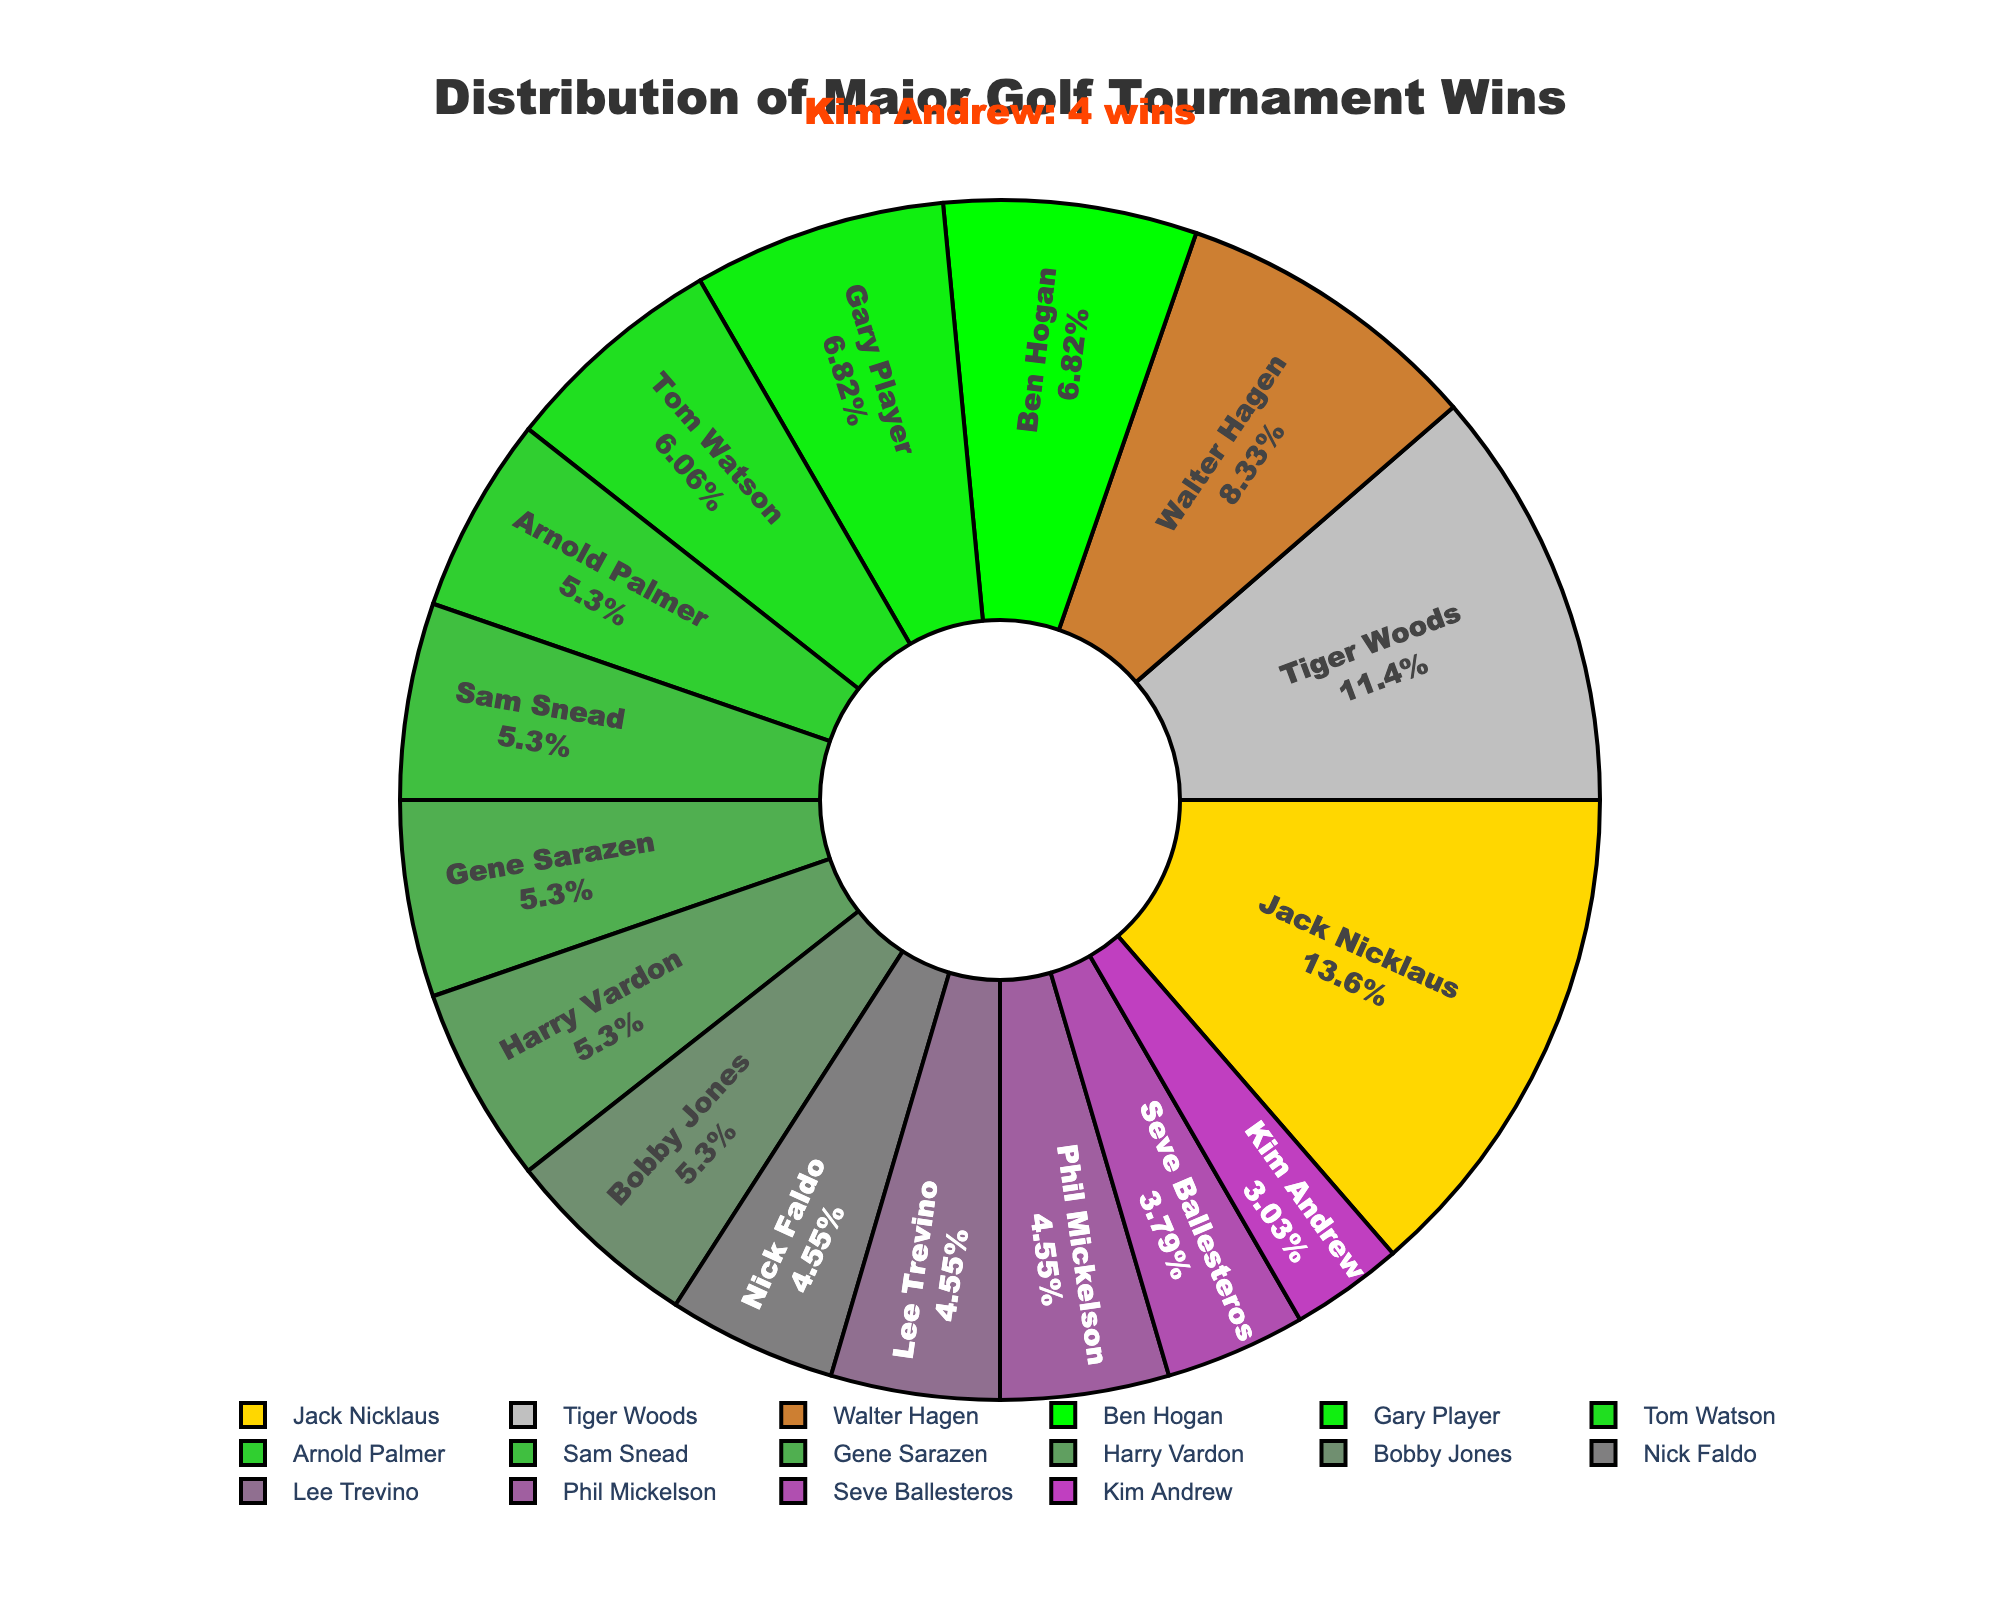What percentage of the total major wins does Kim Andrew have? First, identify Kim Andrew's segment in the pie chart which indicates 4 wins. Then sum the total number of major wins of all players. Total wins = 15 + 18 + 11 + 9 + 9 + 8 + 7 + 7 + 7 + 7 + 7 + 6 + 6 + 5 + 6 + 4 = 132. The percentage is calculated as (4 / 132) * 100 ≈ 3.03%.
Answer: 3.03% How many more major wins does Jack Nicklaus have than Kim Andrew? Locate Jack Nicklaus's segment showing 18 wins and Kim Andrew's segment showing 4 wins. Subtract the wins of Kim Andrew from those of Jack Nicklaus: 18 - 4 = 14.
Answer: 14 Who has a greater number of Major wins, Sam Snead or Kim Andrew, and by how much? Sam Snead has 7 wins, and Kim Andrew has 4 wins. Subtract Kim Andrew's wins from Sam Snead's wins: 7 - 4 = 3.
Answer: Sam Snead by 3 What is the combined total of major wins for Tiger Woods and Ben Hogan? Tiger Woods has 15 wins and Ben Hogan has 9 wins. Add their wins together: 15 + 9 = 24.
Answer: 24 Which player has the third highest number of major wins? First, list the players by their wins in descending order: Jack Nicklaus (18), Tiger Woods (15), Walter Hagen (11). Walter Hagen is third with 11 wins.
Answer: Walter Hagen How many players have won more majors than Kim Andrew? Identify the number of players with more than 4 major wins. They are: Tiger Woods, Jack Nicklaus, Walter Hagen, Ben Hogan, Gary Player, Tom Watson, Arnold Palmer, Sam Snead, Gene Sarazen, Harry Vardon, Bobby Jones, Nick Faldo, Lee Trevino, Phil Mickelson, and Seve Ballesteros, which totals 15 players.
Answer: 15 What is the percentage of wins represented by the top three players together? The top three players are Jack Nicklaus (18), Tiger Woods (15), and Walter Hagen (11). Their combined total is 18 + 15 + 11 = 44. The total number of major wins is 132. The percentage is calculated as (44 / 132) * 100 ≈ 33.33%.
Answer: 33.33% Which player in the bottom three players (in terms of major wins) has a tie, and who are they tied with? The players with the least major wins are Kim Andrew (4) and Seve Ballesteros (5). The bottom three are Seve Ballesteros, Kim Andrew, with Kim Andrew tied at 4. Kim Andrew is not actually tied with another player based on provided data.
Answer: Kim Andrew, no tie What is the difference between the average number of major wins of the top five players and that of the bottom five? The top five players and their wins are: Jack Nicklaus (18), Tiger Woods (15), Walter Hagen (11), Ben Hogan (9), Gary Player (9). Their total wins are 18 + 15 + 11 + 9 + 9 = 62. The average is 62/5 = 12.4. The bottom five players and their wins are: Nick Faldo (6), Lee Trevino (6), Phil Mickelson (6), Seve Ballesteros (5), Kim Andrew (4). Their total wins are 6 + 6 + 6 + 5 + 4 = 27. The average is 27/5 = 5.4. The difference between the averages is 12.4 - 5.4 = 7.
Answer: 7 